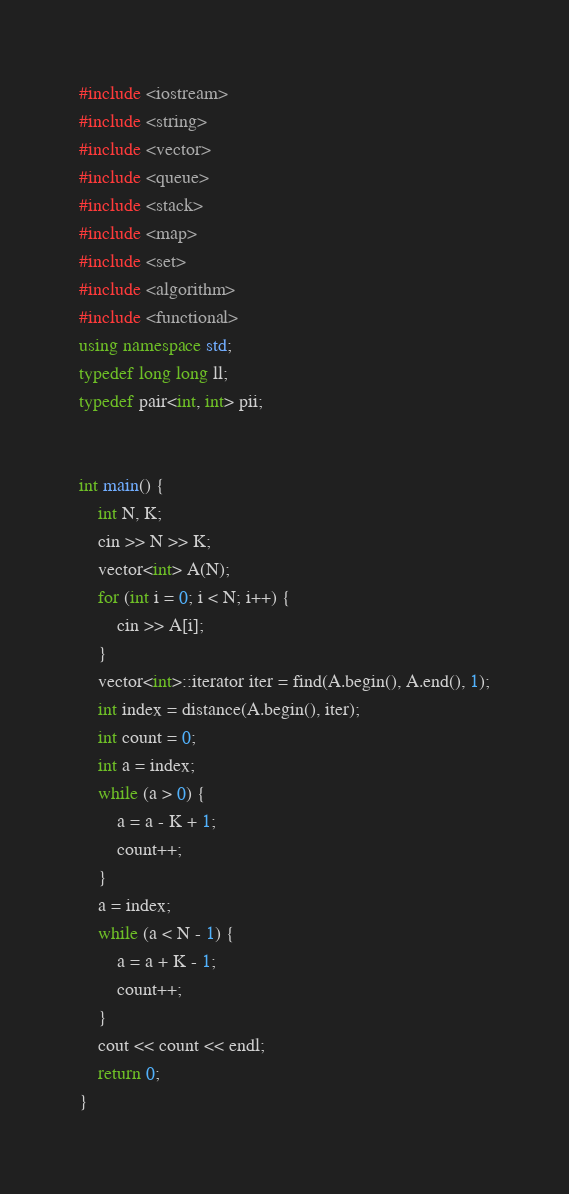Convert code to text. <code><loc_0><loc_0><loc_500><loc_500><_C++_>#include <iostream>
#include <string>
#include <vector>
#include <queue>
#include <stack>
#include <map>
#include <set>
#include <algorithm>
#include <functional>
using namespace std;
typedef long long ll;
typedef pair<int, int> pii;
 
 
int main() {
    int N, K;
    cin >> N >> K;
    vector<int> A(N);
    for (int i = 0; i < N; i++) {
        cin >> A[i];
    }
    vector<int>::iterator iter = find(A.begin(), A.end(), 1);
    int index = distance(A.begin(), iter);
    int count = 0;
    int a = index;
    while (a > 0) {
        a = a - K + 1;
        count++;
    }
    a = index;
    while (a < N - 1) {
        a = a + K - 1;
        count++;
    }
    cout << count << endl;
    return 0;
}
</code> 